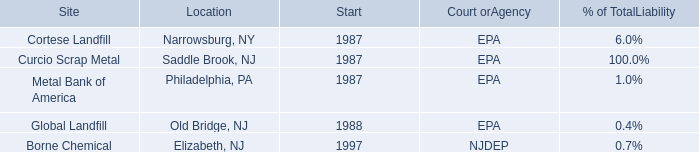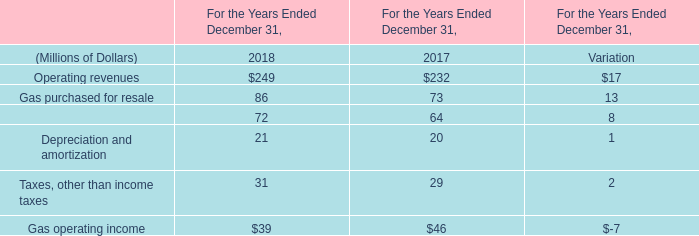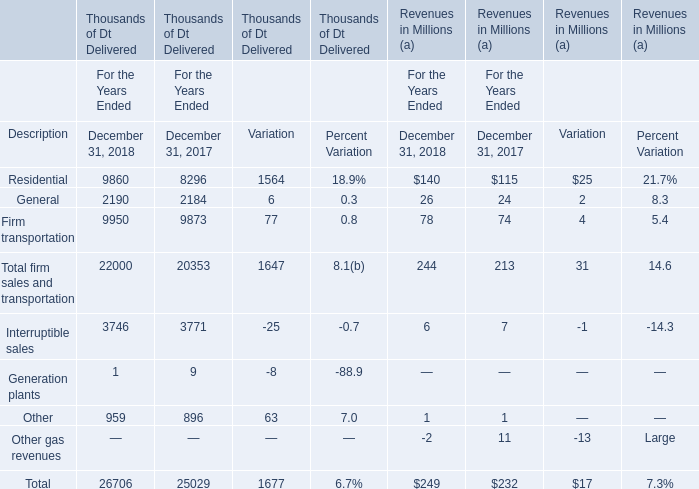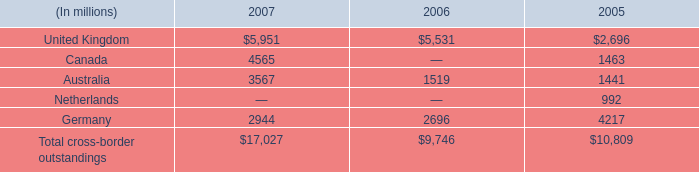What's the increasing rate of other operations and maintenance in 2018? 
Computations: (8 / 64)
Answer: 0.125. 